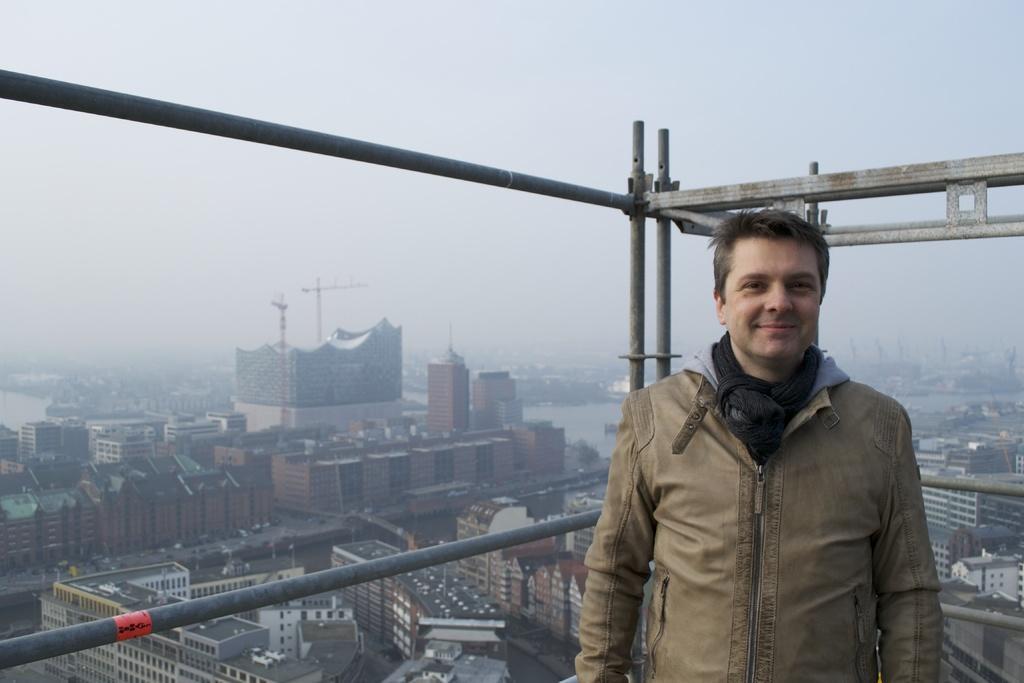Can you describe this image briefly? In this picture I can see a man in front and I see that he is smiling, behind him I can see the poles. In the background I can see number of buildings and the sky. 